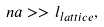<formula> <loc_0><loc_0><loc_500><loc_500>n a > > l _ { l a t t i c e } ,</formula> 